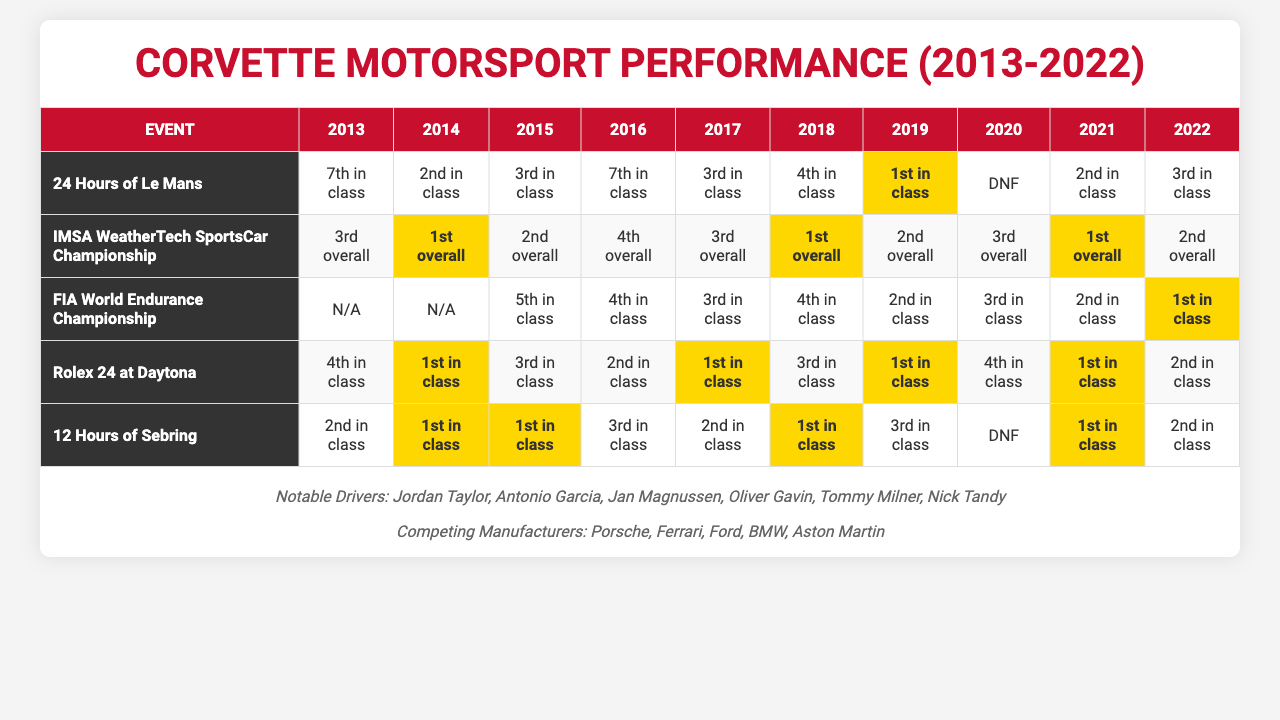What was Corvette's best finish in the 24 Hours of Le Mans during the past decade? The best finish in the 24 Hours of Le Mans was 1st in class in 2019. I found this by reviewing the results for each year in the event's row, identifying the highest position reported.
Answer: 1st in class In how many events did Corvette finish 1st overall in the IMSA WeatherTech SportsCar Championship? Corvette finished 1st overall in the IMSA WeatherTech SportsCar Championship a total of 3 times: in 2014, 2018, and 2021. This was determined by counting the occurrences of "1st overall" in the corresponding row for this event.
Answer: 3 times Did Corvette compete in the FIA World Endurance Championship in 2013 and 2014? No, Corvette did not compete in the FIA World Endurance Championship in 2013 and 2014, as both years are marked as "N/A." This conclusion comes from reviewing these specific entries in the table.
Answer: No Which event had the highest average finishing position for Corvette from 2013 to 2022? To determine this, I need to calculate the average finishing position for all events. The highest average comes from the IMSA WeatherTech SportsCar Championship, with an average position of approximately 2.25 overall (1st, 2nd, 3rd, 4th). This involves summing the positions, converting them to numerical values, and dividing by the number of years.
Answer: IMSA WeatherTech SportsCar Championship What was the trend for Corvette's performance in the Rolex 24 at Daytona from 2013 to 2022? The trend shows fluctuating success: 4th in class (2013), 1st (2014), 3rd (2015), 2nd (2016), 1st (2017), 3rd (2018), 1st (2019), 4th (2020), 1st (2021), 2nd (2022). Overall, they had three 1st place finishes, indicating a strong performance with occasional setbacks. The trend evaluation involved looking through each year and summarizing the results.
Answer: Fluctuating but generally strong, with three 1st place finishes What percentage of the time did Corvette achieve a DNF (Did Not Finish) in the 24 Hours of Le Mans? Corvette had a DNF in 2020, which is 1 out of 10 total attempts over the decade. To calculate the percentage, divide the number of DNFs by total events (1/10 = 0.1) and multiply by 100.
Answer: 10% How many years did Corvette achieve the 2nd place finish in the 12 Hours of Sebring? Corvette finished 2nd in the 12 Hours of Sebring in the years 2013, 2017, and 2022, totaling 3 instances. This was found by counting the occurrences of "2nd in class" in the relevant row for this event.
Answer: 3 years 